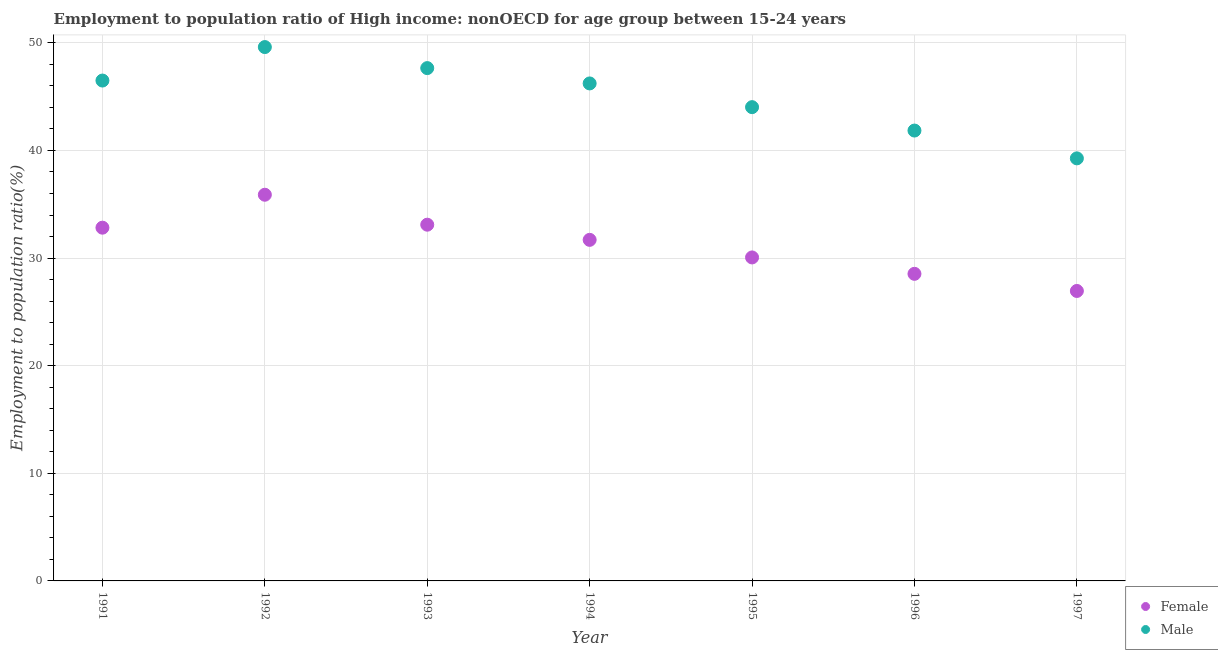How many different coloured dotlines are there?
Make the answer very short. 2. What is the employment to population ratio(male) in 1996?
Keep it short and to the point. 41.85. Across all years, what is the maximum employment to population ratio(female)?
Offer a terse response. 35.89. Across all years, what is the minimum employment to population ratio(female)?
Give a very brief answer. 26.94. What is the total employment to population ratio(female) in the graph?
Provide a short and direct response. 219.05. What is the difference between the employment to population ratio(male) in 1991 and that in 1995?
Your answer should be compact. 2.47. What is the difference between the employment to population ratio(female) in 1993 and the employment to population ratio(male) in 1996?
Give a very brief answer. -8.75. What is the average employment to population ratio(male) per year?
Keep it short and to the point. 45.02. In the year 1992, what is the difference between the employment to population ratio(female) and employment to population ratio(male)?
Offer a very short reply. -13.72. What is the ratio of the employment to population ratio(female) in 1991 to that in 1992?
Your response must be concise. 0.91. What is the difference between the highest and the second highest employment to population ratio(male)?
Your answer should be very brief. 1.95. What is the difference between the highest and the lowest employment to population ratio(female)?
Your response must be concise. 8.94. Is the sum of the employment to population ratio(male) in 1994 and 1995 greater than the maximum employment to population ratio(female) across all years?
Make the answer very short. Yes. Does the employment to population ratio(female) monotonically increase over the years?
Provide a short and direct response. No. Is the employment to population ratio(female) strictly greater than the employment to population ratio(male) over the years?
Offer a terse response. No. How many dotlines are there?
Keep it short and to the point. 2. What is the difference between two consecutive major ticks on the Y-axis?
Offer a very short reply. 10. Does the graph contain any zero values?
Your answer should be very brief. No. Where does the legend appear in the graph?
Keep it short and to the point. Bottom right. What is the title of the graph?
Provide a short and direct response. Employment to population ratio of High income: nonOECD for age group between 15-24 years. What is the Employment to population ratio(%) of Female in 1991?
Your answer should be very brief. 32.83. What is the Employment to population ratio(%) of Male in 1991?
Your answer should be very brief. 46.5. What is the Employment to population ratio(%) in Female in 1992?
Ensure brevity in your answer.  35.89. What is the Employment to population ratio(%) of Male in 1992?
Your response must be concise. 49.61. What is the Employment to population ratio(%) in Female in 1993?
Provide a short and direct response. 33.1. What is the Employment to population ratio(%) of Male in 1993?
Provide a succinct answer. 47.65. What is the Employment to population ratio(%) of Female in 1994?
Your answer should be very brief. 31.69. What is the Employment to population ratio(%) of Male in 1994?
Make the answer very short. 46.23. What is the Employment to population ratio(%) of Female in 1995?
Offer a terse response. 30.06. What is the Employment to population ratio(%) in Male in 1995?
Give a very brief answer. 44.03. What is the Employment to population ratio(%) in Female in 1996?
Provide a short and direct response. 28.54. What is the Employment to population ratio(%) of Male in 1996?
Keep it short and to the point. 41.85. What is the Employment to population ratio(%) in Female in 1997?
Offer a very short reply. 26.94. What is the Employment to population ratio(%) in Male in 1997?
Keep it short and to the point. 39.27. Across all years, what is the maximum Employment to population ratio(%) in Female?
Make the answer very short. 35.89. Across all years, what is the maximum Employment to population ratio(%) in Male?
Provide a short and direct response. 49.61. Across all years, what is the minimum Employment to population ratio(%) of Female?
Make the answer very short. 26.94. Across all years, what is the minimum Employment to population ratio(%) in Male?
Give a very brief answer. 39.27. What is the total Employment to population ratio(%) of Female in the graph?
Your answer should be compact. 219.05. What is the total Employment to population ratio(%) in Male in the graph?
Offer a terse response. 315.13. What is the difference between the Employment to population ratio(%) of Female in 1991 and that in 1992?
Ensure brevity in your answer.  -3.06. What is the difference between the Employment to population ratio(%) in Male in 1991 and that in 1992?
Ensure brevity in your answer.  -3.11. What is the difference between the Employment to population ratio(%) in Female in 1991 and that in 1993?
Offer a terse response. -0.28. What is the difference between the Employment to population ratio(%) of Male in 1991 and that in 1993?
Keep it short and to the point. -1.16. What is the difference between the Employment to population ratio(%) of Female in 1991 and that in 1994?
Offer a terse response. 1.13. What is the difference between the Employment to population ratio(%) of Male in 1991 and that in 1994?
Offer a terse response. 0.27. What is the difference between the Employment to population ratio(%) in Female in 1991 and that in 1995?
Provide a short and direct response. 2.77. What is the difference between the Employment to population ratio(%) of Male in 1991 and that in 1995?
Your response must be concise. 2.47. What is the difference between the Employment to population ratio(%) in Female in 1991 and that in 1996?
Ensure brevity in your answer.  4.29. What is the difference between the Employment to population ratio(%) in Male in 1991 and that in 1996?
Keep it short and to the point. 4.65. What is the difference between the Employment to population ratio(%) in Female in 1991 and that in 1997?
Keep it short and to the point. 5.88. What is the difference between the Employment to population ratio(%) of Male in 1991 and that in 1997?
Your response must be concise. 7.23. What is the difference between the Employment to population ratio(%) in Female in 1992 and that in 1993?
Provide a succinct answer. 2.78. What is the difference between the Employment to population ratio(%) of Male in 1992 and that in 1993?
Provide a succinct answer. 1.95. What is the difference between the Employment to population ratio(%) in Female in 1992 and that in 1994?
Your answer should be very brief. 4.19. What is the difference between the Employment to population ratio(%) in Male in 1992 and that in 1994?
Keep it short and to the point. 3.38. What is the difference between the Employment to population ratio(%) of Female in 1992 and that in 1995?
Offer a terse response. 5.83. What is the difference between the Employment to population ratio(%) in Male in 1992 and that in 1995?
Make the answer very short. 5.58. What is the difference between the Employment to population ratio(%) of Female in 1992 and that in 1996?
Offer a terse response. 7.35. What is the difference between the Employment to population ratio(%) of Male in 1992 and that in 1996?
Ensure brevity in your answer.  7.76. What is the difference between the Employment to population ratio(%) in Female in 1992 and that in 1997?
Provide a succinct answer. 8.94. What is the difference between the Employment to population ratio(%) of Male in 1992 and that in 1997?
Provide a short and direct response. 10.34. What is the difference between the Employment to population ratio(%) of Female in 1993 and that in 1994?
Your response must be concise. 1.41. What is the difference between the Employment to population ratio(%) in Male in 1993 and that in 1994?
Offer a very short reply. 1.42. What is the difference between the Employment to population ratio(%) of Female in 1993 and that in 1995?
Give a very brief answer. 3.04. What is the difference between the Employment to population ratio(%) in Male in 1993 and that in 1995?
Provide a succinct answer. 3.63. What is the difference between the Employment to population ratio(%) in Female in 1993 and that in 1996?
Keep it short and to the point. 4.57. What is the difference between the Employment to population ratio(%) of Male in 1993 and that in 1996?
Your answer should be very brief. 5.8. What is the difference between the Employment to population ratio(%) in Female in 1993 and that in 1997?
Keep it short and to the point. 6.16. What is the difference between the Employment to population ratio(%) of Male in 1993 and that in 1997?
Give a very brief answer. 8.39. What is the difference between the Employment to population ratio(%) in Female in 1994 and that in 1995?
Provide a short and direct response. 1.63. What is the difference between the Employment to population ratio(%) of Male in 1994 and that in 1995?
Give a very brief answer. 2.2. What is the difference between the Employment to population ratio(%) of Female in 1994 and that in 1996?
Your answer should be compact. 3.16. What is the difference between the Employment to population ratio(%) of Male in 1994 and that in 1996?
Your response must be concise. 4.38. What is the difference between the Employment to population ratio(%) of Female in 1994 and that in 1997?
Your response must be concise. 4.75. What is the difference between the Employment to population ratio(%) in Male in 1994 and that in 1997?
Your answer should be very brief. 6.96. What is the difference between the Employment to population ratio(%) in Female in 1995 and that in 1996?
Make the answer very short. 1.52. What is the difference between the Employment to population ratio(%) of Male in 1995 and that in 1996?
Keep it short and to the point. 2.17. What is the difference between the Employment to population ratio(%) of Female in 1995 and that in 1997?
Your answer should be compact. 3.12. What is the difference between the Employment to population ratio(%) in Male in 1995 and that in 1997?
Keep it short and to the point. 4.76. What is the difference between the Employment to population ratio(%) of Female in 1996 and that in 1997?
Keep it short and to the point. 1.59. What is the difference between the Employment to population ratio(%) of Male in 1996 and that in 1997?
Provide a succinct answer. 2.58. What is the difference between the Employment to population ratio(%) of Female in 1991 and the Employment to population ratio(%) of Male in 1992?
Your response must be concise. -16.78. What is the difference between the Employment to population ratio(%) in Female in 1991 and the Employment to population ratio(%) in Male in 1993?
Your answer should be very brief. -14.83. What is the difference between the Employment to population ratio(%) of Female in 1991 and the Employment to population ratio(%) of Male in 1994?
Ensure brevity in your answer.  -13.4. What is the difference between the Employment to population ratio(%) in Female in 1991 and the Employment to population ratio(%) in Male in 1995?
Ensure brevity in your answer.  -11.2. What is the difference between the Employment to population ratio(%) of Female in 1991 and the Employment to population ratio(%) of Male in 1996?
Offer a terse response. -9.03. What is the difference between the Employment to population ratio(%) of Female in 1991 and the Employment to population ratio(%) of Male in 1997?
Give a very brief answer. -6.44. What is the difference between the Employment to population ratio(%) in Female in 1992 and the Employment to population ratio(%) in Male in 1993?
Provide a succinct answer. -11.77. What is the difference between the Employment to population ratio(%) of Female in 1992 and the Employment to population ratio(%) of Male in 1994?
Make the answer very short. -10.34. What is the difference between the Employment to population ratio(%) in Female in 1992 and the Employment to population ratio(%) in Male in 1995?
Your answer should be very brief. -8.14. What is the difference between the Employment to population ratio(%) of Female in 1992 and the Employment to population ratio(%) of Male in 1996?
Your answer should be very brief. -5.96. What is the difference between the Employment to population ratio(%) in Female in 1992 and the Employment to population ratio(%) in Male in 1997?
Ensure brevity in your answer.  -3.38. What is the difference between the Employment to population ratio(%) in Female in 1993 and the Employment to population ratio(%) in Male in 1994?
Offer a very short reply. -13.13. What is the difference between the Employment to population ratio(%) of Female in 1993 and the Employment to population ratio(%) of Male in 1995?
Provide a succinct answer. -10.92. What is the difference between the Employment to population ratio(%) of Female in 1993 and the Employment to population ratio(%) of Male in 1996?
Offer a terse response. -8.75. What is the difference between the Employment to population ratio(%) of Female in 1993 and the Employment to population ratio(%) of Male in 1997?
Provide a succinct answer. -6.16. What is the difference between the Employment to population ratio(%) of Female in 1994 and the Employment to population ratio(%) of Male in 1995?
Keep it short and to the point. -12.33. What is the difference between the Employment to population ratio(%) of Female in 1994 and the Employment to population ratio(%) of Male in 1996?
Provide a short and direct response. -10.16. What is the difference between the Employment to population ratio(%) of Female in 1994 and the Employment to population ratio(%) of Male in 1997?
Provide a succinct answer. -7.57. What is the difference between the Employment to population ratio(%) in Female in 1995 and the Employment to population ratio(%) in Male in 1996?
Provide a short and direct response. -11.79. What is the difference between the Employment to population ratio(%) of Female in 1995 and the Employment to population ratio(%) of Male in 1997?
Provide a short and direct response. -9.21. What is the difference between the Employment to population ratio(%) of Female in 1996 and the Employment to population ratio(%) of Male in 1997?
Provide a short and direct response. -10.73. What is the average Employment to population ratio(%) of Female per year?
Your answer should be very brief. 31.29. What is the average Employment to population ratio(%) of Male per year?
Make the answer very short. 45.02. In the year 1991, what is the difference between the Employment to population ratio(%) in Female and Employment to population ratio(%) in Male?
Give a very brief answer. -13.67. In the year 1992, what is the difference between the Employment to population ratio(%) of Female and Employment to population ratio(%) of Male?
Keep it short and to the point. -13.72. In the year 1993, what is the difference between the Employment to population ratio(%) in Female and Employment to population ratio(%) in Male?
Give a very brief answer. -14.55. In the year 1994, what is the difference between the Employment to population ratio(%) in Female and Employment to population ratio(%) in Male?
Your answer should be compact. -14.54. In the year 1995, what is the difference between the Employment to population ratio(%) in Female and Employment to population ratio(%) in Male?
Your answer should be very brief. -13.97. In the year 1996, what is the difference between the Employment to population ratio(%) of Female and Employment to population ratio(%) of Male?
Ensure brevity in your answer.  -13.31. In the year 1997, what is the difference between the Employment to population ratio(%) in Female and Employment to population ratio(%) in Male?
Give a very brief answer. -12.32. What is the ratio of the Employment to population ratio(%) in Female in 1991 to that in 1992?
Keep it short and to the point. 0.91. What is the ratio of the Employment to population ratio(%) in Male in 1991 to that in 1992?
Provide a succinct answer. 0.94. What is the ratio of the Employment to population ratio(%) in Female in 1991 to that in 1993?
Your answer should be very brief. 0.99. What is the ratio of the Employment to population ratio(%) of Male in 1991 to that in 1993?
Provide a short and direct response. 0.98. What is the ratio of the Employment to population ratio(%) of Female in 1991 to that in 1994?
Your answer should be compact. 1.04. What is the ratio of the Employment to population ratio(%) of Male in 1991 to that in 1994?
Make the answer very short. 1.01. What is the ratio of the Employment to population ratio(%) in Female in 1991 to that in 1995?
Offer a terse response. 1.09. What is the ratio of the Employment to population ratio(%) in Male in 1991 to that in 1995?
Offer a very short reply. 1.06. What is the ratio of the Employment to population ratio(%) in Female in 1991 to that in 1996?
Your answer should be compact. 1.15. What is the ratio of the Employment to population ratio(%) in Male in 1991 to that in 1996?
Give a very brief answer. 1.11. What is the ratio of the Employment to population ratio(%) in Female in 1991 to that in 1997?
Your answer should be compact. 1.22. What is the ratio of the Employment to population ratio(%) in Male in 1991 to that in 1997?
Keep it short and to the point. 1.18. What is the ratio of the Employment to population ratio(%) of Female in 1992 to that in 1993?
Provide a succinct answer. 1.08. What is the ratio of the Employment to population ratio(%) of Male in 1992 to that in 1993?
Provide a succinct answer. 1.04. What is the ratio of the Employment to population ratio(%) of Female in 1992 to that in 1994?
Give a very brief answer. 1.13. What is the ratio of the Employment to population ratio(%) in Male in 1992 to that in 1994?
Make the answer very short. 1.07. What is the ratio of the Employment to population ratio(%) in Female in 1992 to that in 1995?
Give a very brief answer. 1.19. What is the ratio of the Employment to population ratio(%) in Male in 1992 to that in 1995?
Ensure brevity in your answer.  1.13. What is the ratio of the Employment to population ratio(%) of Female in 1992 to that in 1996?
Ensure brevity in your answer.  1.26. What is the ratio of the Employment to population ratio(%) of Male in 1992 to that in 1996?
Keep it short and to the point. 1.19. What is the ratio of the Employment to population ratio(%) in Female in 1992 to that in 1997?
Offer a terse response. 1.33. What is the ratio of the Employment to population ratio(%) of Male in 1992 to that in 1997?
Ensure brevity in your answer.  1.26. What is the ratio of the Employment to population ratio(%) of Female in 1993 to that in 1994?
Make the answer very short. 1.04. What is the ratio of the Employment to population ratio(%) of Male in 1993 to that in 1994?
Offer a very short reply. 1.03. What is the ratio of the Employment to population ratio(%) of Female in 1993 to that in 1995?
Your answer should be very brief. 1.1. What is the ratio of the Employment to population ratio(%) in Male in 1993 to that in 1995?
Offer a terse response. 1.08. What is the ratio of the Employment to population ratio(%) of Female in 1993 to that in 1996?
Provide a succinct answer. 1.16. What is the ratio of the Employment to population ratio(%) in Male in 1993 to that in 1996?
Provide a short and direct response. 1.14. What is the ratio of the Employment to population ratio(%) in Female in 1993 to that in 1997?
Your response must be concise. 1.23. What is the ratio of the Employment to population ratio(%) of Male in 1993 to that in 1997?
Provide a succinct answer. 1.21. What is the ratio of the Employment to population ratio(%) of Female in 1994 to that in 1995?
Offer a terse response. 1.05. What is the ratio of the Employment to population ratio(%) of Male in 1994 to that in 1995?
Your answer should be very brief. 1.05. What is the ratio of the Employment to population ratio(%) in Female in 1994 to that in 1996?
Keep it short and to the point. 1.11. What is the ratio of the Employment to population ratio(%) of Male in 1994 to that in 1996?
Keep it short and to the point. 1.1. What is the ratio of the Employment to population ratio(%) in Female in 1994 to that in 1997?
Keep it short and to the point. 1.18. What is the ratio of the Employment to population ratio(%) in Male in 1994 to that in 1997?
Provide a short and direct response. 1.18. What is the ratio of the Employment to population ratio(%) in Female in 1995 to that in 1996?
Provide a short and direct response. 1.05. What is the ratio of the Employment to population ratio(%) of Male in 1995 to that in 1996?
Offer a very short reply. 1.05. What is the ratio of the Employment to population ratio(%) in Female in 1995 to that in 1997?
Your answer should be very brief. 1.12. What is the ratio of the Employment to population ratio(%) of Male in 1995 to that in 1997?
Your answer should be compact. 1.12. What is the ratio of the Employment to population ratio(%) of Female in 1996 to that in 1997?
Make the answer very short. 1.06. What is the ratio of the Employment to population ratio(%) in Male in 1996 to that in 1997?
Make the answer very short. 1.07. What is the difference between the highest and the second highest Employment to population ratio(%) of Female?
Ensure brevity in your answer.  2.78. What is the difference between the highest and the second highest Employment to population ratio(%) of Male?
Offer a very short reply. 1.95. What is the difference between the highest and the lowest Employment to population ratio(%) in Female?
Offer a very short reply. 8.94. What is the difference between the highest and the lowest Employment to population ratio(%) in Male?
Give a very brief answer. 10.34. 